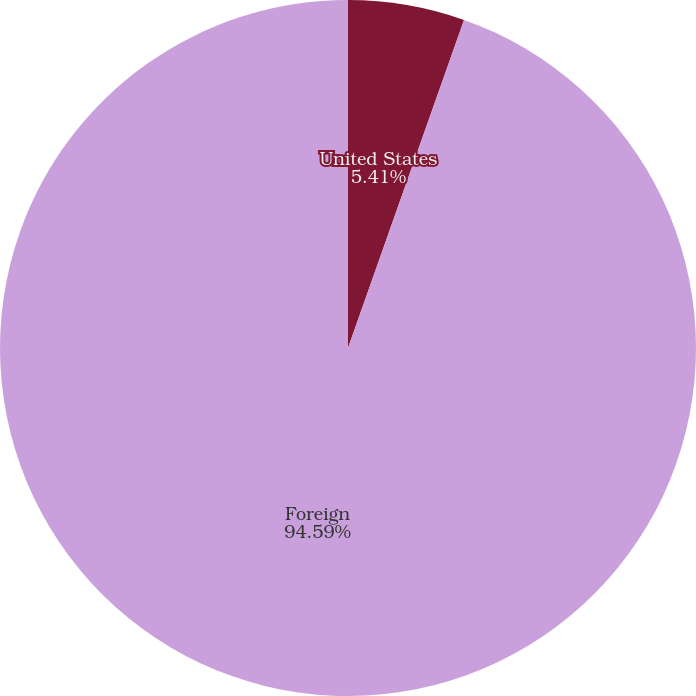Convert chart to OTSL. <chart><loc_0><loc_0><loc_500><loc_500><pie_chart><fcel>United States<fcel>Foreign<nl><fcel>5.41%<fcel>94.59%<nl></chart> 